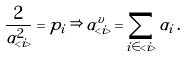Convert formula to latex. <formula><loc_0><loc_0><loc_500><loc_500>\frac { 2 } { \alpha ^ { 2 } _ { < i > } } = p _ { i } \, \Rightarrow \, \alpha _ { < i > } ^ { v } = \sum _ { i \in < i > } \alpha _ { i } \, .</formula> 